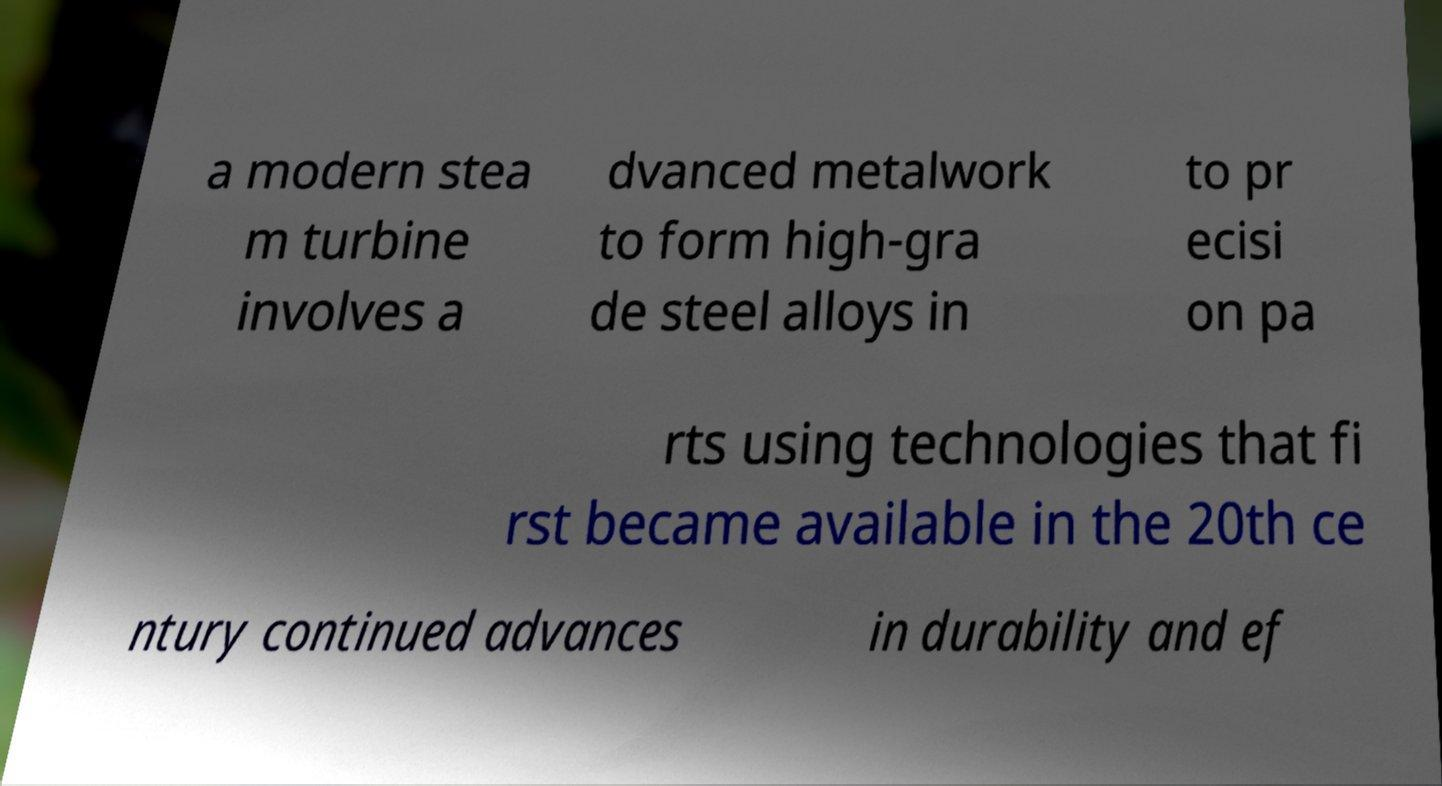For documentation purposes, I need the text within this image transcribed. Could you provide that? a modern stea m turbine involves a dvanced metalwork to form high-gra de steel alloys in to pr ecisi on pa rts using technologies that fi rst became available in the 20th ce ntury continued advances in durability and ef 